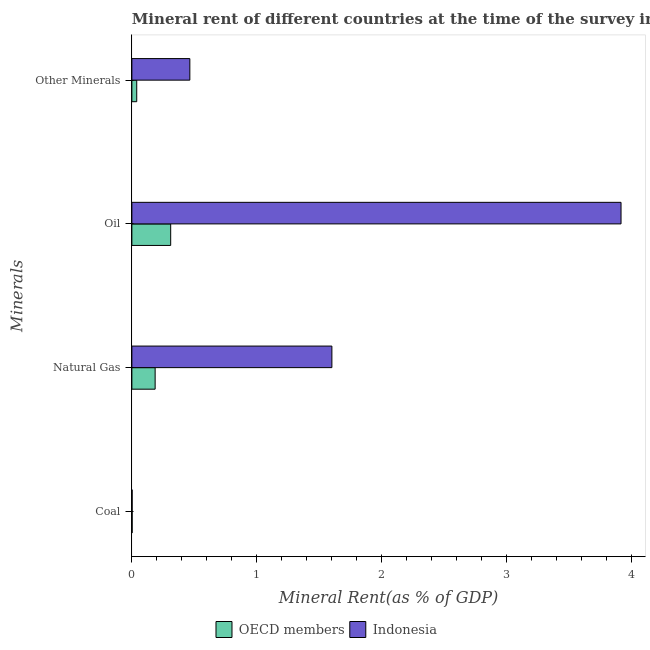How many groups of bars are there?
Your response must be concise. 4. Are the number of bars per tick equal to the number of legend labels?
Your response must be concise. Yes. How many bars are there on the 2nd tick from the top?
Provide a short and direct response. 2. What is the label of the 3rd group of bars from the top?
Make the answer very short. Natural Gas. What is the coal rent in Indonesia?
Offer a terse response. 0. Across all countries, what is the maximum natural gas rent?
Give a very brief answer. 1.6. Across all countries, what is the minimum coal rent?
Provide a short and direct response. 0. What is the total  rent of other minerals in the graph?
Provide a short and direct response. 0.5. What is the difference between the coal rent in OECD members and that in Indonesia?
Offer a terse response. 0. What is the difference between the coal rent in OECD members and the oil rent in Indonesia?
Offer a terse response. -3.92. What is the average coal rent per country?
Ensure brevity in your answer.  0. What is the difference between the oil rent and natural gas rent in OECD members?
Your answer should be very brief. 0.12. In how many countries, is the oil rent greater than 1.6 %?
Give a very brief answer. 1. What is the ratio of the natural gas rent in Indonesia to that in OECD members?
Make the answer very short. 8.6. Is the difference between the natural gas rent in OECD members and Indonesia greater than the difference between the oil rent in OECD members and Indonesia?
Provide a succinct answer. Yes. What is the difference between the highest and the second highest coal rent?
Provide a succinct answer. 0. What is the difference between the highest and the lowest natural gas rent?
Make the answer very short. 1.42. Is the sum of the natural gas rent in Indonesia and OECD members greater than the maximum oil rent across all countries?
Provide a short and direct response. No. Is it the case that in every country, the sum of the  rent of other minerals and coal rent is greater than the sum of natural gas rent and oil rent?
Your answer should be very brief. No. What does the 1st bar from the top in Oil represents?
Offer a terse response. Indonesia. What does the 1st bar from the bottom in Coal represents?
Provide a succinct answer. OECD members. How many bars are there?
Your answer should be very brief. 8. Are all the bars in the graph horizontal?
Your answer should be very brief. Yes. What is the difference between two consecutive major ticks on the X-axis?
Provide a short and direct response. 1. Are the values on the major ticks of X-axis written in scientific E-notation?
Make the answer very short. No. Does the graph contain any zero values?
Your answer should be compact. No. How many legend labels are there?
Offer a very short reply. 2. How are the legend labels stacked?
Provide a short and direct response. Horizontal. What is the title of the graph?
Your response must be concise. Mineral rent of different countries at the time of the survey in 1993. Does "Bosnia and Herzegovina" appear as one of the legend labels in the graph?
Provide a succinct answer. No. What is the label or title of the X-axis?
Your answer should be compact. Mineral Rent(as % of GDP). What is the label or title of the Y-axis?
Keep it short and to the point. Minerals. What is the Mineral Rent(as % of GDP) in OECD members in Coal?
Offer a terse response. 0. What is the Mineral Rent(as % of GDP) in Indonesia in Coal?
Your answer should be very brief. 0. What is the Mineral Rent(as % of GDP) in OECD members in Natural Gas?
Your response must be concise. 0.19. What is the Mineral Rent(as % of GDP) of Indonesia in Natural Gas?
Provide a short and direct response. 1.6. What is the Mineral Rent(as % of GDP) in OECD members in Oil?
Keep it short and to the point. 0.31. What is the Mineral Rent(as % of GDP) in Indonesia in Oil?
Offer a terse response. 3.92. What is the Mineral Rent(as % of GDP) of OECD members in Other Minerals?
Provide a succinct answer. 0.04. What is the Mineral Rent(as % of GDP) of Indonesia in Other Minerals?
Provide a succinct answer. 0.46. Across all Minerals, what is the maximum Mineral Rent(as % of GDP) of OECD members?
Your answer should be very brief. 0.31. Across all Minerals, what is the maximum Mineral Rent(as % of GDP) of Indonesia?
Offer a very short reply. 3.92. Across all Minerals, what is the minimum Mineral Rent(as % of GDP) of OECD members?
Your response must be concise. 0. Across all Minerals, what is the minimum Mineral Rent(as % of GDP) of Indonesia?
Your response must be concise. 0. What is the total Mineral Rent(as % of GDP) of OECD members in the graph?
Your answer should be very brief. 0.54. What is the total Mineral Rent(as % of GDP) in Indonesia in the graph?
Keep it short and to the point. 5.99. What is the difference between the Mineral Rent(as % of GDP) in OECD members in Coal and that in Natural Gas?
Offer a terse response. -0.18. What is the difference between the Mineral Rent(as % of GDP) of Indonesia in Coal and that in Natural Gas?
Ensure brevity in your answer.  -1.6. What is the difference between the Mineral Rent(as % of GDP) of OECD members in Coal and that in Oil?
Provide a short and direct response. -0.31. What is the difference between the Mineral Rent(as % of GDP) of Indonesia in Coal and that in Oil?
Ensure brevity in your answer.  -3.92. What is the difference between the Mineral Rent(as % of GDP) of OECD members in Coal and that in Other Minerals?
Provide a short and direct response. -0.04. What is the difference between the Mineral Rent(as % of GDP) of Indonesia in Coal and that in Other Minerals?
Offer a very short reply. -0.46. What is the difference between the Mineral Rent(as % of GDP) of OECD members in Natural Gas and that in Oil?
Your answer should be very brief. -0.12. What is the difference between the Mineral Rent(as % of GDP) in Indonesia in Natural Gas and that in Oil?
Make the answer very short. -2.32. What is the difference between the Mineral Rent(as % of GDP) of OECD members in Natural Gas and that in Other Minerals?
Your response must be concise. 0.15. What is the difference between the Mineral Rent(as % of GDP) in Indonesia in Natural Gas and that in Other Minerals?
Keep it short and to the point. 1.14. What is the difference between the Mineral Rent(as % of GDP) in OECD members in Oil and that in Other Minerals?
Keep it short and to the point. 0.27. What is the difference between the Mineral Rent(as % of GDP) of Indonesia in Oil and that in Other Minerals?
Provide a short and direct response. 3.45. What is the difference between the Mineral Rent(as % of GDP) of OECD members in Coal and the Mineral Rent(as % of GDP) of Indonesia in Natural Gas?
Give a very brief answer. -1.6. What is the difference between the Mineral Rent(as % of GDP) in OECD members in Coal and the Mineral Rent(as % of GDP) in Indonesia in Oil?
Make the answer very short. -3.92. What is the difference between the Mineral Rent(as % of GDP) of OECD members in Coal and the Mineral Rent(as % of GDP) of Indonesia in Other Minerals?
Offer a very short reply. -0.46. What is the difference between the Mineral Rent(as % of GDP) of OECD members in Natural Gas and the Mineral Rent(as % of GDP) of Indonesia in Oil?
Your response must be concise. -3.73. What is the difference between the Mineral Rent(as % of GDP) of OECD members in Natural Gas and the Mineral Rent(as % of GDP) of Indonesia in Other Minerals?
Offer a terse response. -0.28. What is the difference between the Mineral Rent(as % of GDP) in OECD members in Oil and the Mineral Rent(as % of GDP) in Indonesia in Other Minerals?
Offer a terse response. -0.15. What is the average Mineral Rent(as % of GDP) in OECD members per Minerals?
Your answer should be compact. 0.13. What is the average Mineral Rent(as % of GDP) of Indonesia per Minerals?
Offer a terse response. 1.5. What is the difference between the Mineral Rent(as % of GDP) in OECD members and Mineral Rent(as % of GDP) in Indonesia in Coal?
Your answer should be very brief. 0. What is the difference between the Mineral Rent(as % of GDP) in OECD members and Mineral Rent(as % of GDP) in Indonesia in Natural Gas?
Make the answer very short. -1.42. What is the difference between the Mineral Rent(as % of GDP) of OECD members and Mineral Rent(as % of GDP) of Indonesia in Oil?
Ensure brevity in your answer.  -3.61. What is the difference between the Mineral Rent(as % of GDP) of OECD members and Mineral Rent(as % of GDP) of Indonesia in Other Minerals?
Provide a short and direct response. -0.43. What is the ratio of the Mineral Rent(as % of GDP) of OECD members in Coal to that in Natural Gas?
Ensure brevity in your answer.  0.01. What is the ratio of the Mineral Rent(as % of GDP) in Indonesia in Coal to that in Natural Gas?
Provide a short and direct response. 0. What is the ratio of the Mineral Rent(as % of GDP) of OECD members in Coal to that in Oil?
Your answer should be compact. 0.01. What is the ratio of the Mineral Rent(as % of GDP) in OECD members in Coal to that in Other Minerals?
Ensure brevity in your answer.  0.06. What is the ratio of the Mineral Rent(as % of GDP) of Indonesia in Coal to that in Other Minerals?
Your answer should be compact. 0. What is the ratio of the Mineral Rent(as % of GDP) in OECD members in Natural Gas to that in Oil?
Keep it short and to the point. 0.6. What is the ratio of the Mineral Rent(as % of GDP) in Indonesia in Natural Gas to that in Oil?
Offer a very short reply. 0.41. What is the ratio of the Mineral Rent(as % of GDP) in OECD members in Natural Gas to that in Other Minerals?
Make the answer very short. 4.78. What is the ratio of the Mineral Rent(as % of GDP) of Indonesia in Natural Gas to that in Other Minerals?
Your answer should be compact. 3.45. What is the ratio of the Mineral Rent(as % of GDP) in OECD members in Oil to that in Other Minerals?
Your answer should be very brief. 7.98. What is the ratio of the Mineral Rent(as % of GDP) of Indonesia in Oil to that in Other Minerals?
Your answer should be compact. 8.44. What is the difference between the highest and the second highest Mineral Rent(as % of GDP) of OECD members?
Provide a succinct answer. 0.12. What is the difference between the highest and the second highest Mineral Rent(as % of GDP) of Indonesia?
Your response must be concise. 2.32. What is the difference between the highest and the lowest Mineral Rent(as % of GDP) of OECD members?
Your answer should be compact. 0.31. What is the difference between the highest and the lowest Mineral Rent(as % of GDP) in Indonesia?
Ensure brevity in your answer.  3.92. 